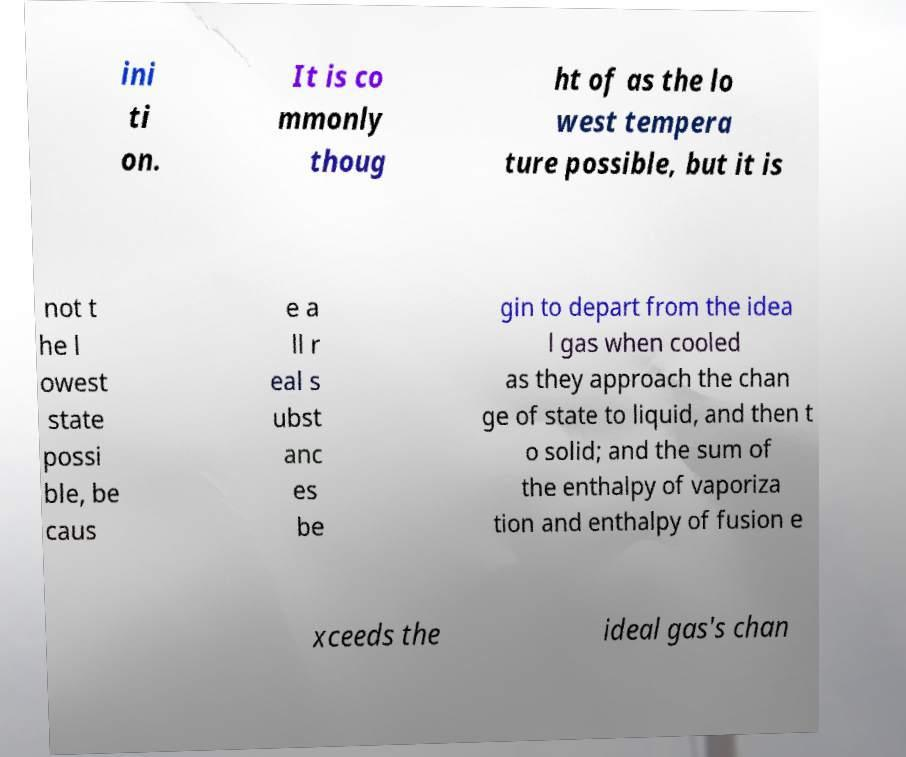Please identify and transcribe the text found in this image. ini ti on. It is co mmonly thoug ht of as the lo west tempera ture possible, but it is not t he l owest state possi ble, be caus e a ll r eal s ubst anc es be gin to depart from the idea l gas when cooled as they approach the chan ge of state to liquid, and then t o solid; and the sum of the enthalpy of vaporiza tion and enthalpy of fusion e xceeds the ideal gas's chan 